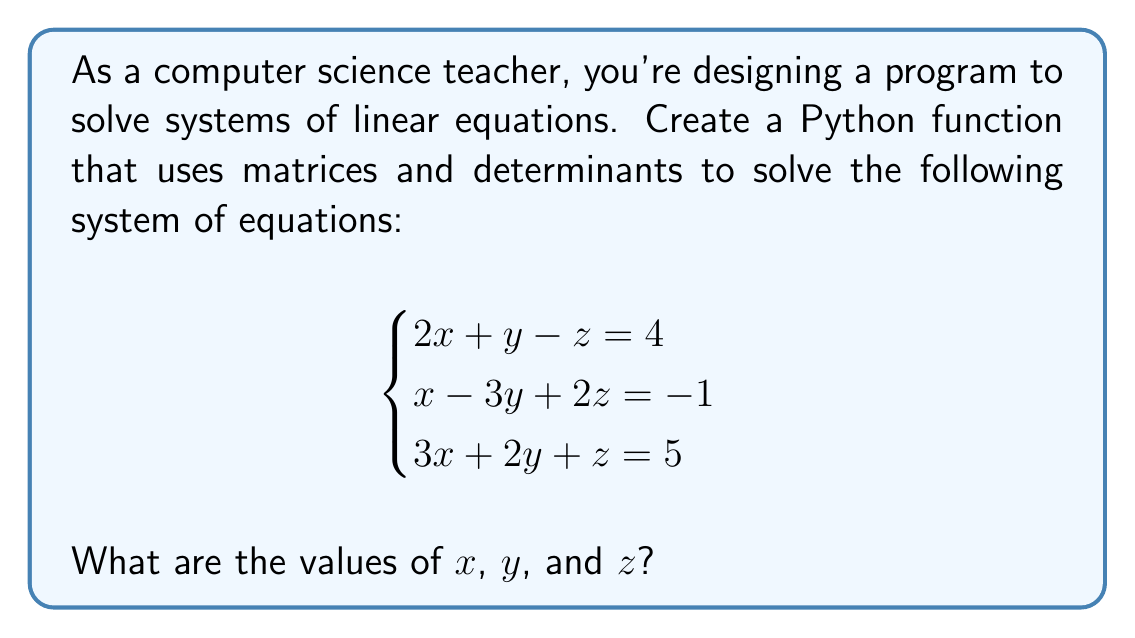Can you solve this math problem? To solve this system using matrices and determinants, we'll follow these steps:

1) First, we'll set up the coefficient matrix $A$ and the constant matrix $B$:

   $$A = \begin{bmatrix}
   2 & 1 & -1 \\
   1 & -3 & 2 \\
   3 & 2 & 1
   \end{bmatrix}, \quad B = \begin{bmatrix}
   4 \\
   -1 \\
   5
   \end{bmatrix}$$

2) We'll use Cramer's rule to solve for $x$, $y$, and $z$. For this, we need to calculate the determinant of $A$ and the determinants of matrices where we replace columns with $B$.

3) Calculate $\det(A)$:
   $$\det(A) = 2(-3-4) + 1(2-3) + (-1)(6+1) = -14 - 1 - 7 = -22$$

4) Calculate $\det(A_x)$ (replace first column with $B$):
   $$\det(A_x) = 4(-3-4) + 1(10+1) + (-1)(-15-4) = -28 + 11 + 19 = 2$$

5) Calculate $\det(A_y)$ (replace second column with $B$):
   $$\det(A_y) = 2(-1-20) + 4(2-3) + (-1)(8+5) = -42 - 4 - 13 = -59$$

6) Calculate $\det(A_z)$ (replace third column with $B$):
   $$\det(A_z) = 2(5+1) + 1(-15-4) + 4(6+1) = 12 - 19 + 28 = 21$$

7) Apply Cramer's rule:
   $$x = \frac{\det(A_x)}{\det(A)} = \frac{2}{-22} = -\frac{1}{11}$$
   $$y = \frac{\det(A_y)}{\det(A)} = \frac{-59}{-22} = \frac{59}{22}$$
   $$z = \frac{\det(A_z)}{\det(A)} = \frac{21}{-22} = -\frac{21}{22}$$

Therefore, the solution to the system is $x = -\frac{1}{11}$, $y = \frac{59}{22}$, and $z = -\frac{21}{22}$.
Answer: $x = -\frac{1}{11}$, $y = \frac{59}{22}$, $z = -\frac{21}{22}$ 